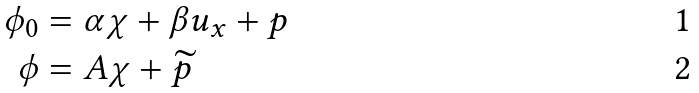Convert formula to latex. <formula><loc_0><loc_0><loc_500><loc_500>\phi _ { 0 } & = \alpha \chi + \beta u _ { x } + p \\ \phi & = A \chi + \widetilde { p }</formula> 